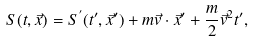Convert formula to latex. <formula><loc_0><loc_0><loc_500><loc_500>S ( t , \vec { x } ) = S ^ { ^ { \prime } } ( t ^ { \prime } , \vec { x } ^ { \prime } ) + m \vec { v } \cdot \vec { x } ^ { \prime } + \frac { m } { 2 } \vec { v } ^ { 2 } t ^ { \prime } ,</formula> 